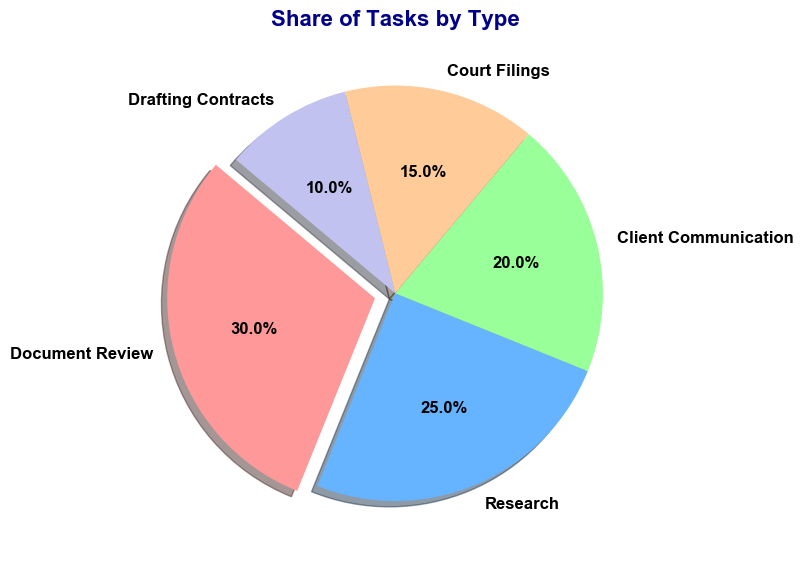What percentage of the tasks is represented by Client Communication and Document Review together? To find the percentage of tasks represented by Client Communication and Document Review together, add their respective shares. Client Communication is 20%, and Document Review is 30%. The sum is 20% + 30% = 50%.
Answer: 50% Which task type has the smallest share of tasks? Look at the pie chart and identify the task type with the smallest percentage. Drafting Contracts is indicated with a 10% share, which is the smallest among all task types.
Answer: Drafting Contracts What is the difference in the share of tasks between Research and Court Filings? To compute the difference, subtract the share of Court Filings from the share of Research. Research has a share of 25%, and Court Filings have a share of 15%. The difference is 25% - 15% = 10%.
Answer: 10% What color is associated with Research in the pie chart? The visual attribute of color associated with Research in the pie chart is blue. This can be determined by visually inspecting the chart and noting the color segment labeled as Research.
Answer: Blue Which task type has a greater share, Client Communication or Court Filings, and by how much? Compare the shares of Client Communication (20%) and Court Filings (15%). Client Communication has a greater share. The difference is 20% - 15% = 5%.
Answer: Client Communication, 5% If Document Review, Research, and Court Filings are combined, what would their total share be? Add the shares of Document Review (30%), Research (25%), and Court Filings (15%). The total share is 30% + 25% + 15% = 70%.
Answer: 70% Which task type is represented by the largest section of the pie chart? Identify the largest section of the pie chart by comparing the percentages. Document Review, with a 30% share, is the largest section.
Answer: Document Review How much more of the share of tasks does Document Review have compared to Drafting Contracts? Subtract the share of Drafting Contracts (10%) from the share of Document Review (30%). The difference is 30% - 10% = 20%.
Answer: 20% Is the share of tasks for Research closer to Document Review or Client Communication? Calculate the differences between Research and the other two task types. The difference between Research (25%) and Document Review (30%) is 30% - 25% = 5%. The difference between Research (25%) and Client Communication (20%) is 25% - 20% = 5%. Both differences are equal.
Answer: Equidistant If you were to combine the shares of Client Communication and Drafting Contracts, would their total share be more or less than that of Document Review? Add the shares of Client Communication (20%) and Drafting Contracts (10%). The total share is 20% + 10% = 30%, which is equal to the share of Document Review (30%).
Answer: Equal 